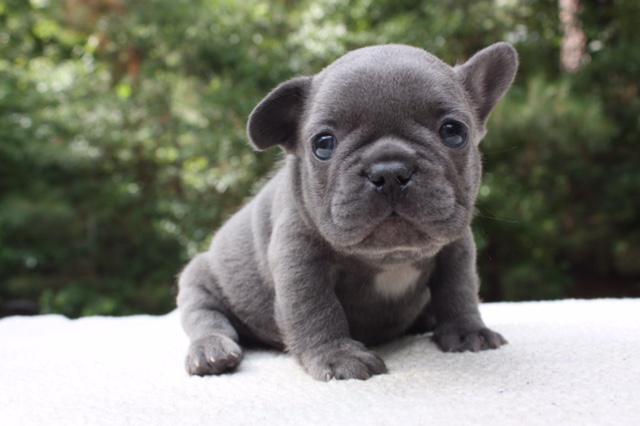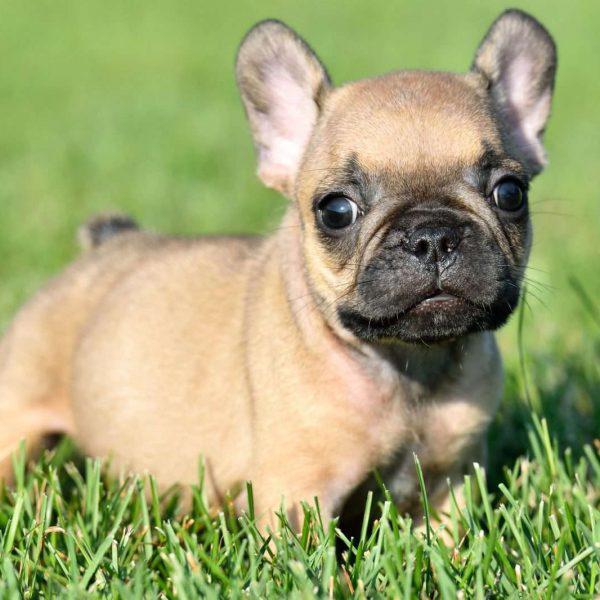The first image is the image on the left, the second image is the image on the right. Given the left and right images, does the statement "In one of the images, there are more than two puppies." hold true? Answer yes or no. No. The first image is the image on the left, the second image is the image on the right. For the images displayed, is the sentence "The dog in the image on the right is on grass." factually correct? Answer yes or no. Yes. The first image is the image on the left, the second image is the image on the right. Analyze the images presented: Is the assertion "Exactly one puppy is standing alone in the grass." valid? Answer yes or no. Yes. The first image is the image on the left, the second image is the image on the right. For the images displayed, is the sentence "An image shows a trio of puppies with a black one in the middle." factually correct? Answer yes or no. No. 